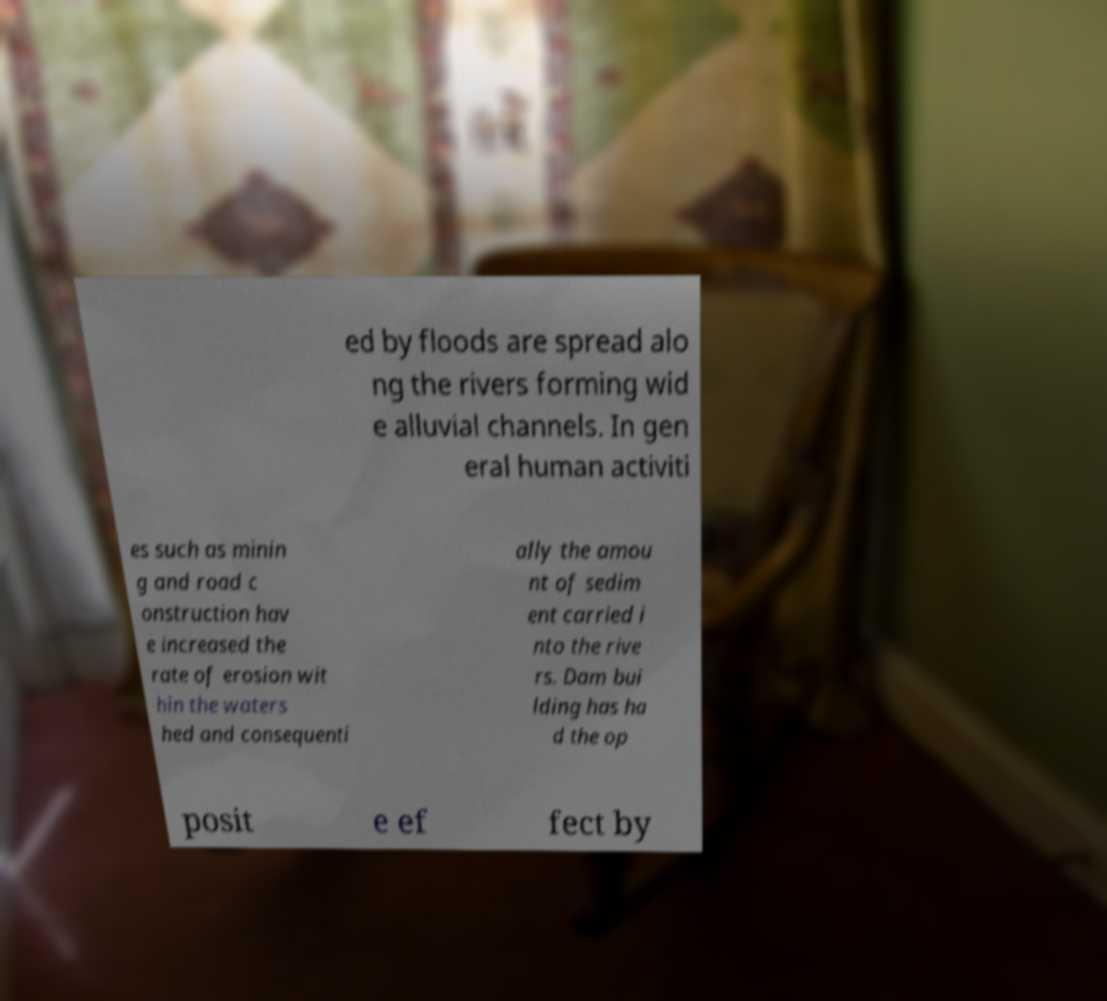What messages or text are displayed in this image? I need them in a readable, typed format. ed by floods are spread alo ng the rivers forming wid e alluvial channels. In gen eral human activiti es such as minin g and road c onstruction hav e increased the rate of erosion wit hin the waters hed and consequenti ally the amou nt of sedim ent carried i nto the rive rs. Dam bui lding has ha d the op posit e ef fect by 